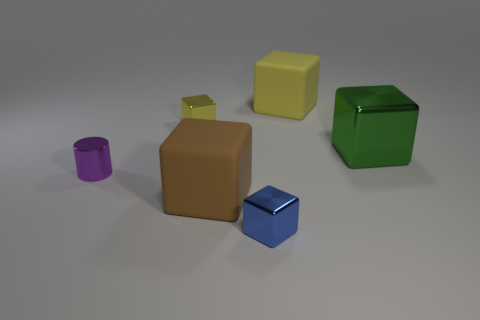Subtract all large metallic blocks. How many blocks are left? 4 Add 1 small yellow shiny spheres. How many objects exist? 7 Subtract all yellow blocks. How many blocks are left? 3 Add 1 small gray cubes. How many small gray cubes exist? 1 Subtract 0 cyan blocks. How many objects are left? 6 Subtract all cylinders. How many objects are left? 5 Subtract 5 blocks. How many blocks are left? 0 Subtract all brown cubes. Subtract all brown cylinders. How many cubes are left? 4 Subtract all purple cylinders. How many purple blocks are left? 0 Subtract all large cyan matte objects. Subtract all big blocks. How many objects are left? 3 